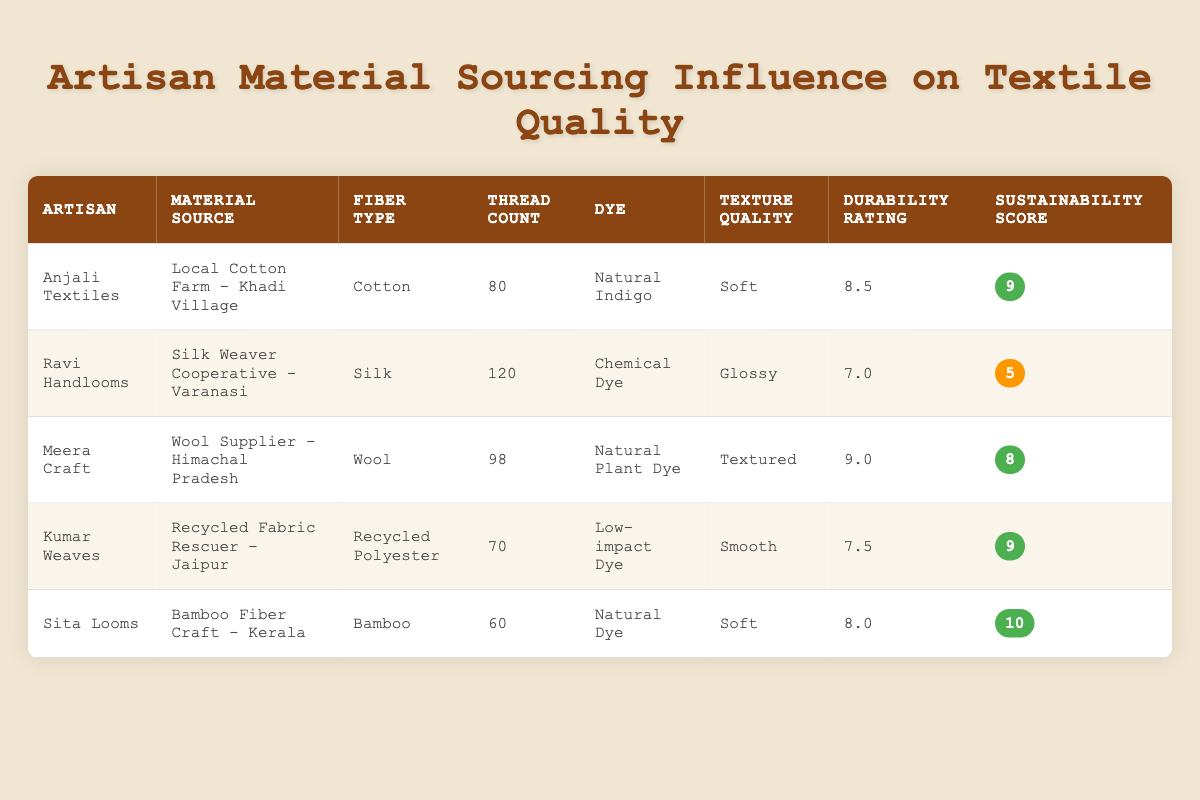What is the thread count of Sita Looms’ fabrics? The table directly shows 'Thread Count' as one of the columns, and for Sita Looms, the corresponding value is 60.
Answer: 60 Which artisan has the highest durability rating? By looking at the 'Durability Rating' column, Meera Craft has the highest value of 9.0 compared to the others.
Answer: Meera Craft What is the difference in sustainability scores between Ravi Handlooms and Kumar Weaves? The sustainability score for Ravi Handlooms is 5 and for Kumar Weaves is 9. To find the difference, we calculate 9 - 5, which equals 4.
Answer: 4 Is it true that all artisans using natural dyes have a sustainability score of 8 or higher? Checking the artisans who used natural dyes: Anjali Textiles (9), Meera Craft (8), and Sita Looms (10). Since all these scores are 8 or higher, the statement is true.
Answer: Yes What is the average thread count for items made by artisans using natural materials? The artisans using natural materials are Anjali Textiles (80), Meera Craft (98), and Sita Looms (60). Adding these gives 80 + 98 + 60 = 238. Dividing by the number of artisans (3), we find the average is 238 / 3 = 79.33.
Answer: 79.33 Which fiber type has the lowest durability rating? Looking at the 'Durability Rating' column, Ravi Handlooms has the lowest rating of 7.0 amongst the fiber types listed.
Answer: Silk How many artisans have a sustainability score of 9 or above? The artisans with sustainability scores of 9 or above are Anjali Textiles, Kumar Weaves, and Sita Looms. Counting these gives us a total of 3 artisans.
Answer: 3 What is the texture quality of textiles made by Kumar Weaves? The 'Texture Quality' column shows that Kumar Weaves has a texture quality listed as 'Smooth'.
Answer: Smooth Does any artisan have a sustainability score of 10? The table indicates that Sita Looms has a sustainability score of 10. Therefore, there is at least one artisan with this score.
Answer: Yes 